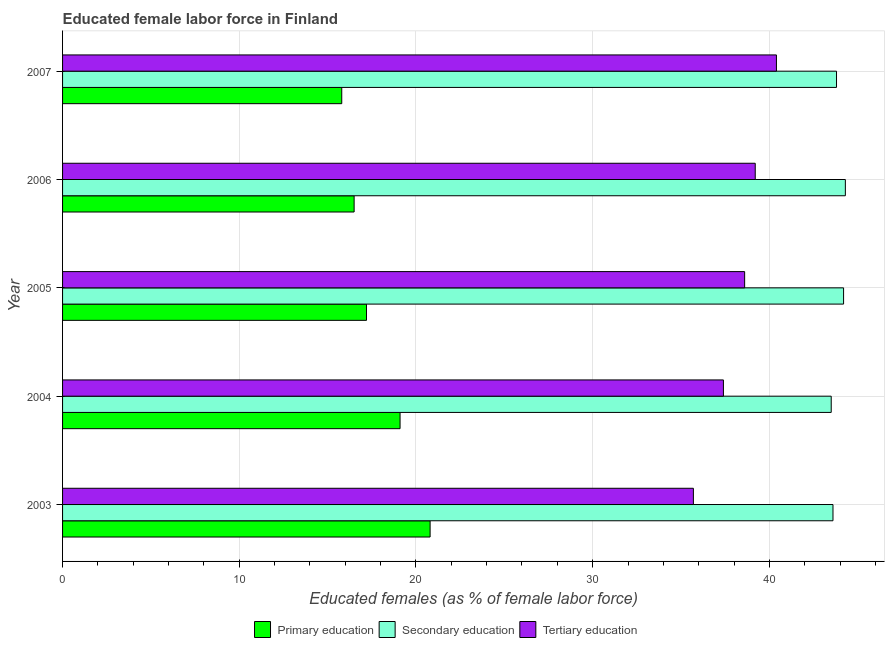How many different coloured bars are there?
Offer a terse response. 3. How many groups of bars are there?
Your response must be concise. 5. Are the number of bars per tick equal to the number of legend labels?
Make the answer very short. Yes. Are the number of bars on each tick of the Y-axis equal?
Offer a terse response. Yes. In how many cases, is the number of bars for a given year not equal to the number of legend labels?
Provide a succinct answer. 0. What is the percentage of female labor force who received primary education in 2007?
Keep it short and to the point. 15.8. Across all years, what is the maximum percentage of female labor force who received secondary education?
Offer a terse response. 44.3. Across all years, what is the minimum percentage of female labor force who received primary education?
Offer a very short reply. 15.8. In which year was the percentage of female labor force who received tertiary education maximum?
Keep it short and to the point. 2007. What is the total percentage of female labor force who received tertiary education in the graph?
Ensure brevity in your answer.  191.3. What is the difference between the percentage of female labor force who received tertiary education in 2003 and the percentage of female labor force who received secondary education in 2006?
Make the answer very short. -8.6. What is the average percentage of female labor force who received primary education per year?
Your answer should be very brief. 17.88. In the year 2006, what is the difference between the percentage of female labor force who received tertiary education and percentage of female labor force who received primary education?
Your response must be concise. 22.7. In how many years, is the percentage of female labor force who received secondary education greater than 26 %?
Provide a short and direct response. 5. What is the ratio of the percentage of female labor force who received primary education in 2003 to that in 2006?
Keep it short and to the point. 1.26. Is the percentage of female labor force who received tertiary education in 2004 less than that in 2006?
Provide a succinct answer. Yes. In how many years, is the percentage of female labor force who received tertiary education greater than the average percentage of female labor force who received tertiary education taken over all years?
Your answer should be compact. 3. What does the 1st bar from the top in 2005 represents?
Your response must be concise. Tertiary education. What does the 2nd bar from the bottom in 2003 represents?
Offer a terse response. Secondary education. Is it the case that in every year, the sum of the percentage of female labor force who received primary education and percentage of female labor force who received secondary education is greater than the percentage of female labor force who received tertiary education?
Your response must be concise. Yes. How many bars are there?
Provide a short and direct response. 15. Are all the bars in the graph horizontal?
Make the answer very short. Yes. What is the difference between two consecutive major ticks on the X-axis?
Make the answer very short. 10. Are the values on the major ticks of X-axis written in scientific E-notation?
Ensure brevity in your answer.  No. Does the graph contain any zero values?
Provide a short and direct response. No. Does the graph contain grids?
Your response must be concise. Yes. Where does the legend appear in the graph?
Keep it short and to the point. Bottom center. How many legend labels are there?
Your answer should be compact. 3. What is the title of the graph?
Provide a short and direct response. Educated female labor force in Finland. Does "Renewable sources" appear as one of the legend labels in the graph?
Offer a terse response. No. What is the label or title of the X-axis?
Offer a very short reply. Educated females (as % of female labor force). What is the label or title of the Y-axis?
Offer a very short reply. Year. What is the Educated females (as % of female labor force) in Primary education in 2003?
Provide a short and direct response. 20.8. What is the Educated females (as % of female labor force) in Secondary education in 2003?
Your response must be concise. 43.6. What is the Educated females (as % of female labor force) of Tertiary education in 2003?
Provide a succinct answer. 35.7. What is the Educated females (as % of female labor force) in Primary education in 2004?
Provide a succinct answer. 19.1. What is the Educated females (as % of female labor force) of Secondary education in 2004?
Offer a terse response. 43.5. What is the Educated females (as % of female labor force) of Tertiary education in 2004?
Your answer should be very brief. 37.4. What is the Educated females (as % of female labor force) of Primary education in 2005?
Provide a short and direct response. 17.2. What is the Educated females (as % of female labor force) in Secondary education in 2005?
Provide a short and direct response. 44.2. What is the Educated females (as % of female labor force) of Tertiary education in 2005?
Offer a very short reply. 38.6. What is the Educated females (as % of female labor force) in Secondary education in 2006?
Your answer should be very brief. 44.3. What is the Educated females (as % of female labor force) in Tertiary education in 2006?
Your answer should be compact. 39.2. What is the Educated females (as % of female labor force) of Primary education in 2007?
Your answer should be compact. 15.8. What is the Educated females (as % of female labor force) in Secondary education in 2007?
Offer a very short reply. 43.8. What is the Educated females (as % of female labor force) of Tertiary education in 2007?
Provide a short and direct response. 40.4. Across all years, what is the maximum Educated females (as % of female labor force) in Primary education?
Your response must be concise. 20.8. Across all years, what is the maximum Educated females (as % of female labor force) of Secondary education?
Ensure brevity in your answer.  44.3. Across all years, what is the maximum Educated females (as % of female labor force) in Tertiary education?
Offer a terse response. 40.4. Across all years, what is the minimum Educated females (as % of female labor force) in Primary education?
Make the answer very short. 15.8. Across all years, what is the minimum Educated females (as % of female labor force) in Secondary education?
Make the answer very short. 43.5. Across all years, what is the minimum Educated females (as % of female labor force) in Tertiary education?
Ensure brevity in your answer.  35.7. What is the total Educated females (as % of female labor force) in Primary education in the graph?
Your answer should be very brief. 89.4. What is the total Educated females (as % of female labor force) in Secondary education in the graph?
Your answer should be very brief. 219.4. What is the total Educated females (as % of female labor force) in Tertiary education in the graph?
Make the answer very short. 191.3. What is the difference between the Educated females (as % of female labor force) of Primary education in 2003 and that in 2005?
Keep it short and to the point. 3.6. What is the difference between the Educated females (as % of female labor force) of Tertiary education in 2003 and that in 2006?
Ensure brevity in your answer.  -3.5. What is the difference between the Educated females (as % of female labor force) of Primary education in 2003 and that in 2007?
Offer a very short reply. 5. What is the difference between the Educated females (as % of female labor force) of Secondary education in 2004 and that in 2005?
Your answer should be compact. -0.7. What is the difference between the Educated females (as % of female labor force) in Tertiary education in 2004 and that in 2005?
Your answer should be compact. -1.2. What is the difference between the Educated females (as % of female labor force) in Secondary education in 2004 and that in 2006?
Your answer should be compact. -0.8. What is the difference between the Educated females (as % of female labor force) of Primary education in 2004 and that in 2007?
Provide a succinct answer. 3.3. What is the difference between the Educated females (as % of female labor force) of Secondary education in 2004 and that in 2007?
Provide a short and direct response. -0.3. What is the difference between the Educated females (as % of female labor force) in Tertiary education in 2004 and that in 2007?
Your answer should be compact. -3. What is the difference between the Educated females (as % of female labor force) of Tertiary education in 2005 and that in 2006?
Make the answer very short. -0.6. What is the difference between the Educated females (as % of female labor force) in Primary education in 2005 and that in 2007?
Offer a terse response. 1.4. What is the difference between the Educated females (as % of female labor force) in Secondary education in 2006 and that in 2007?
Make the answer very short. 0.5. What is the difference between the Educated females (as % of female labor force) of Primary education in 2003 and the Educated females (as % of female labor force) of Secondary education in 2004?
Offer a very short reply. -22.7. What is the difference between the Educated females (as % of female labor force) of Primary education in 2003 and the Educated females (as % of female labor force) of Tertiary education in 2004?
Keep it short and to the point. -16.6. What is the difference between the Educated females (as % of female labor force) of Primary education in 2003 and the Educated females (as % of female labor force) of Secondary education in 2005?
Your response must be concise. -23.4. What is the difference between the Educated females (as % of female labor force) of Primary education in 2003 and the Educated females (as % of female labor force) of Tertiary education in 2005?
Make the answer very short. -17.8. What is the difference between the Educated females (as % of female labor force) of Primary education in 2003 and the Educated females (as % of female labor force) of Secondary education in 2006?
Your answer should be compact. -23.5. What is the difference between the Educated females (as % of female labor force) of Primary education in 2003 and the Educated females (as % of female labor force) of Tertiary education in 2006?
Offer a very short reply. -18.4. What is the difference between the Educated females (as % of female labor force) of Primary education in 2003 and the Educated females (as % of female labor force) of Tertiary education in 2007?
Offer a terse response. -19.6. What is the difference between the Educated females (as % of female labor force) in Secondary education in 2003 and the Educated females (as % of female labor force) in Tertiary education in 2007?
Give a very brief answer. 3.2. What is the difference between the Educated females (as % of female labor force) in Primary education in 2004 and the Educated females (as % of female labor force) in Secondary education in 2005?
Ensure brevity in your answer.  -25.1. What is the difference between the Educated females (as % of female labor force) of Primary education in 2004 and the Educated females (as % of female labor force) of Tertiary education in 2005?
Provide a short and direct response. -19.5. What is the difference between the Educated females (as % of female labor force) of Primary education in 2004 and the Educated females (as % of female labor force) of Secondary education in 2006?
Your answer should be very brief. -25.2. What is the difference between the Educated females (as % of female labor force) of Primary education in 2004 and the Educated females (as % of female labor force) of Tertiary education in 2006?
Provide a short and direct response. -20.1. What is the difference between the Educated females (as % of female labor force) of Secondary education in 2004 and the Educated females (as % of female labor force) of Tertiary education in 2006?
Your answer should be compact. 4.3. What is the difference between the Educated females (as % of female labor force) in Primary education in 2004 and the Educated females (as % of female labor force) in Secondary education in 2007?
Provide a succinct answer. -24.7. What is the difference between the Educated females (as % of female labor force) in Primary education in 2004 and the Educated females (as % of female labor force) in Tertiary education in 2007?
Keep it short and to the point. -21.3. What is the difference between the Educated females (as % of female labor force) of Primary education in 2005 and the Educated females (as % of female labor force) of Secondary education in 2006?
Your answer should be compact. -27.1. What is the difference between the Educated females (as % of female labor force) of Primary education in 2005 and the Educated females (as % of female labor force) of Tertiary education in 2006?
Make the answer very short. -22. What is the difference between the Educated females (as % of female labor force) of Secondary education in 2005 and the Educated females (as % of female labor force) of Tertiary education in 2006?
Provide a succinct answer. 5. What is the difference between the Educated females (as % of female labor force) of Primary education in 2005 and the Educated females (as % of female labor force) of Secondary education in 2007?
Offer a terse response. -26.6. What is the difference between the Educated females (as % of female labor force) in Primary education in 2005 and the Educated females (as % of female labor force) in Tertiary education in 2007?
Offer a very short reply. -23.2. What is the difference between the Educated females (as % of female labor force) in Primary education in 2006 and the Educated females (as % of female labor force) in Secondary education in 2007?
Provide a short and direct response. -27.3. What is the difference between the Educated females (as % of female labor force) of Primary education in 2006 and the Educated females (as % of female labor force) of Tertiary education in 2007?
Make the answer very short. -23.9. What is the difference between the Educated females (as % of female labor force) in Secondary education in 2006 and the Educated females (as % of female labor force) in Tertiary education in 2007?
Provide a succinct answer. 3.9. What is the average Educated females (as % of female labor force) of Primary education per year?
Offer a very short reply. 17.88. What is the average Educated females (as % of female labor force) in Secondary education per year?
Provide a short and direct response. 43.88. What is the average Educated females (as % of female labor force) in Tertiary education per year?
Your response must be concise. 38.26. In the year 2003, what is the difference between the Educated females (as % of female labor force) in Primary education and Educated females (as % of female labor force) in Secondary education?
Your answer should be compact. -22.8. In the year 2003, what is the difference between the Educated females (as % of female labor force) in Primary education and Educated females (as % of female labor force) in Tertiary education?
Offer a terse response. -14.9. In the year 2004, what is the difference between the Educated females (as % of female labor force) in Primary education and Educated females (as % of female labor force) in Secondary education?
Your answer should be compact. -24.4. In the year 2004, what is the difference between the Educated females (as % of female labor force) in Primary education and Educated females (as % of female labor force) in Tertiary education?
Make the answer very short. -18.3. In the year 2005, what is the difference between the Educated females (as % of female labor force) in Primary education and Educated females (as % of female labor force) in Secondary education?
Offer a very short reply. -27. In the year 2005, what is the difference between the Educated females (as % of female labor force) in Primary education and Educated females (as % of female labor force) in Tertiary education?
Give a very brief answer. -21.4. In the year 2005, what is the difference between the Educated females (as % of female labor force) in Secondary education and Educated females (as % of female labor force) in Tertiary education?
Offer a terse response. 5.6. In the year 2006, what is the difference between the Educated females (as % of female labor force) in Primary education and Educated females (as % of female labor force) in Secondary education?
Offer a terse response. -27.8. In the year 2006, what is the difference between the Educated females (as % of female labor force) of Primary education and Educated females (as % of female labor force) of Tertiary education?
Ensure brevity in your answer.  -22.7. In the year 2007, what is the difference between the Educated females (as % of female labor force) of Primary education and Educated females (as % of female labor force) of Secondary education?
Offer a very short reply. -28. In the year 2007, what is the difference between the Educated females (as % of female labor force) of Primary education and Educated females (as % of female labor force) of Tertiary education?
Make the answer very short. -24.6. What is the ratio of the Educated females (as % of female labor force) of Primary education in 2003 to that in 2004?
Your response must be concise. 1.09. What is the ratio of the Educated females (as % of female labor force) in Secondary education in 2003 to that in 2004?
Your answer should be compact. 1. What is the ratio of the Educated females (as % of female labor force) of Tertiary education in 2003 to that in 2004?
Ensure brevity in your answer.  0.95. What is the ratio of the Educated females (as % of female labor force) in Primary education in 2003 to that in 2005?
Keep it short and to the point. 1.21. What is the ratio of the Educated females (as % of female labor force) in Secondary education in 2003 to that in 2005?
Give a very brief answer. 0.99. What is the ratio of the Educated females (as % of female labor force) of Tertiary education in 2003 to that in 2005?
Make the answer very short. 0.92. What is the ratio of the Educated females (as % of female labor force) of Primary education in 2003 to that in 2006?
Make the answer very short. 1.26. What is the ratio of the Educated females (as % of female labor force) in Secondary education in 2003 to that in 2006?
Offer a very short reply. 0.98. What is the ratio of the Educated females (as % of female labor force) in Tertiary education in 2003 to that in 2006?
Give a very brief answer. 0.91. What is the ratio of the Educated females (as % of female labor force) in Primary education in 2003 to that in 2007?
Give a very brief answer. 1.32. What is the ratio of the Educated females (as % of female labor force) of Secondary education in 2003 to that in 2007?
Keep it short and to the point. 1. What is the ratio of the Educated females (as % of female labor force) of Tertiary education in 2003 to that in 2007?
Offer a terse response. 0.88. What is the ratio of the Educated females (as % of female labor force) in Primary education in 2004 to that in 2005?
Make the answer very short. 1.11. What is the ratio of the Educated females (as % of female labor force) of Secondary education in 2004 to that in 2005?
Your response must be concise. 0.98. What is the ratio of the Educated females (as % of female labor force) in Tertiary education in 2004 to that in 2005?
Ensure brevity in your answer.  0.97. What is the ratio of the Educated females (as % of female labor force) in Primary education in 2004 to that in 2006?
Your answer should be compact. 1.16. What is the ratio of the Educated females (as % of female labor force) of Secondary education in 2004 to that in 2006?
Your answer should be compact. 0.98. What is the ratio of the Educated females (as % of female labor force) in Tertiary education in 2004 to that in 2006?
Your answer should be very brief. 0.95. What is the ratio of the Educated females (as % of female labor force) of Primary education in 2004 to that in 2007?
Ensure brevity in your answer.  1.21. What is the ratio of the Educated females (as % of female labor force) of Secondary education in 2004 to that in 2007?
Ensure brevity in your answer.  0.99. What is the ratio of the Educated females (as % of female labor force) in Tertiary education in 2004 to that in 2007?
Your answer should be compact. 0.93. What is the ratio of the Educated females (as % of female labor force) in Primary education in 2005 to that in 2006?
Ensure brevity in your answer.  1.04. What is the ratio of the Educated females (as % of female labor force) in Secondary education in 2005 to that in 2006?
Provide a short and direct response. 1. What is the ratio of the Educated females (as % of female labor force) in Tertiary education in 2005 to that in 2006?
Keep it short and to the point. 0.98. What is the ratio of the Educated females (as % of female labor force) in Primary education in 2005 to that in 2007?
Provide a succinct answer. 1.09. What is the ratio of the Educated females (as % of female labor force) of Secondary education in 2005 to that in 2007?
Provide a succinct answer. 1.01. What is the ratio of the Educated females (as % of female labor force) in Tertiary education in 2005 to that in 2007?
Your answer should be compact. 0.96. What is the ratio of the Educated females (as % of female labor force) in Primary education in 2006 to that in 2007?
Keep it short and to the point. 1.04. What is the ratio of the Educated females (as % of female labor force) of Secondary education in 2006 to that in 2007?
Make the answer very short. 1.01. What is the ratio of the Educated females (as % of female labor force) of Tertiary education in 2006 to that in 2007?
Give a very brief answer. 0.97. What is the difference between the highest and the second highest Educated females (as % of female labor force) of Primary education?
Your answer should be very brief. 1.7. What is the difference between the highest and the second highest Educated females (as % of female labor force) in Tertiary education?
Your answer should be compact. 1.2. What is the difference between the highest and the lowest Educated females (as % of female labor force) of Primary education?
Offer a very short reply. 5. 